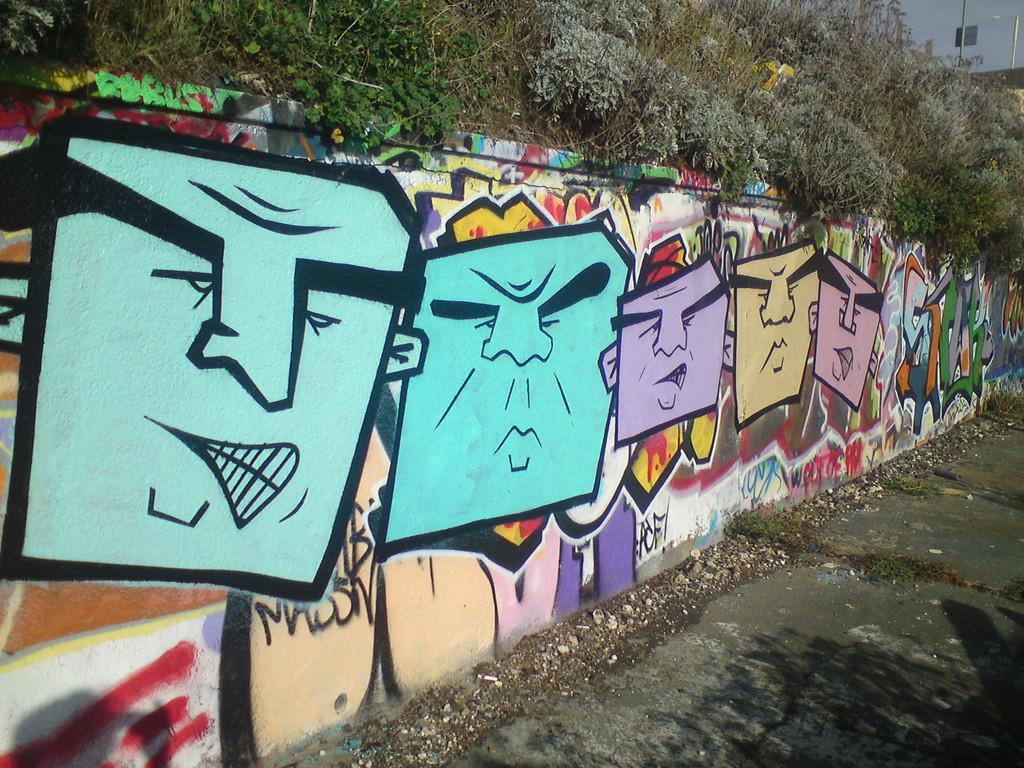In one or two sentences, can you explain what this image depicts? In this picture I can observe a wall. There is a graffiti art on the wall. I can observe blue, purple, cream and red colors on the wall. There are some trees and plants. In the background there is a sky. 